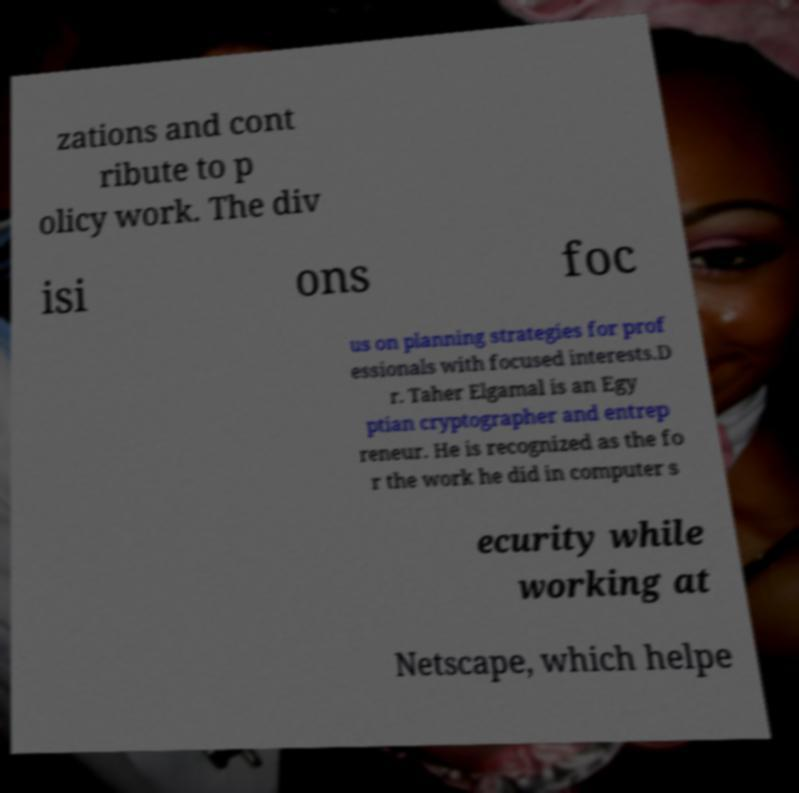Please read and relay the text visible in this image. What does it say? zations and cont ribute to p olicy work. The div isi ons foc us on planning strategies for prof essionals with focused interests.D r. Taher Elgamal is an Egy ptian cryptographer and entrep reneur. He is recognized as the fo r the work he did in computer s ecurity while working at Netscape, which helpe 